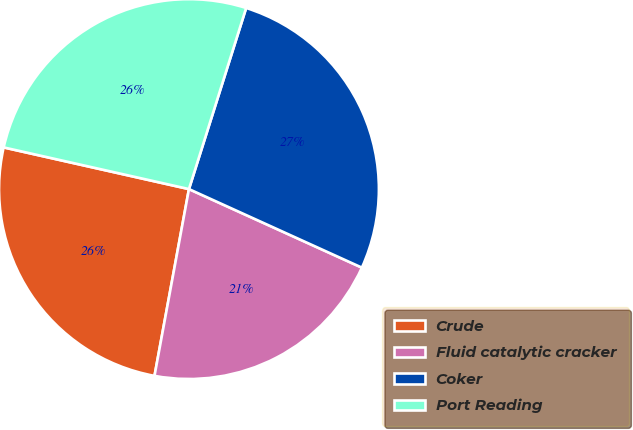Convert chart to OTSL. <chart><loc_0><loc_0><loc_500><loc_500><pie_chart><fcel>Crude<fcel>Fluid catalytic cracker<fcel>Coker<fcel>Port Reading<nl><fcel>25.62%<fcel>21.12%<fcel>26.92%<fcel>26.35%<nl></chart> 